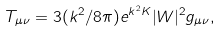Convert formula to latex. <formula><loc_0><loc_0><loc_500><loc_500>T _ { \mu \nu } = 3 ( k ^ { 2 } / 8 \pi ) e ^ { k ^ { 2 } K } | W | ^ { 2 } g _ { \mu \nu } ,</formula> 